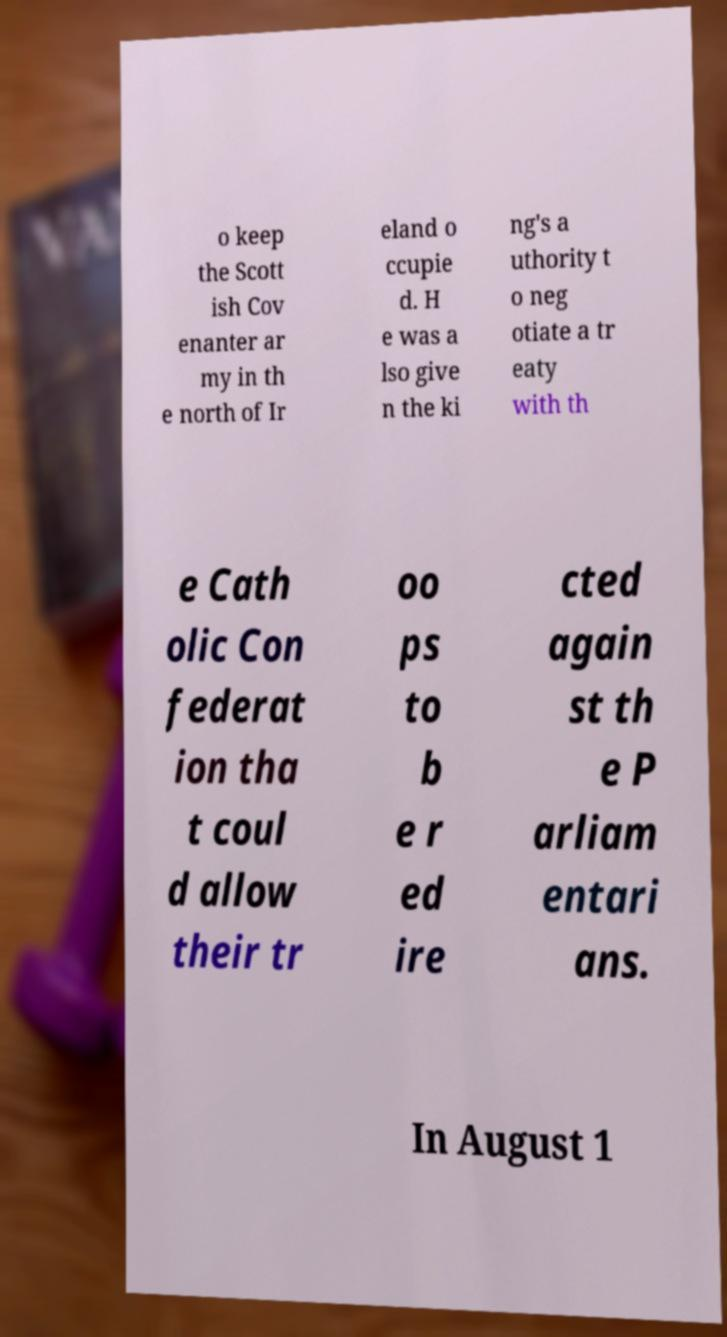Can you accurately transcribe the text from the provided image for me? o keep the Scott ish Cov enanter ar my in th e north of Ir eland o ccupie d. H e was a lso give n the ki ng's a uthority t o neg otiate a tr eaty with th e Cath olic Con federat ion tha t coul d allow their tr oo ps to b e r ed ire cted again st th e P arliam entari ans. In August 1 